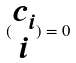<formula> <loc_0><loc_0><loc_500><loc_500>( \begin{matrix} c _ { i } \\ i \end{matrix} ) = 0</formula> 